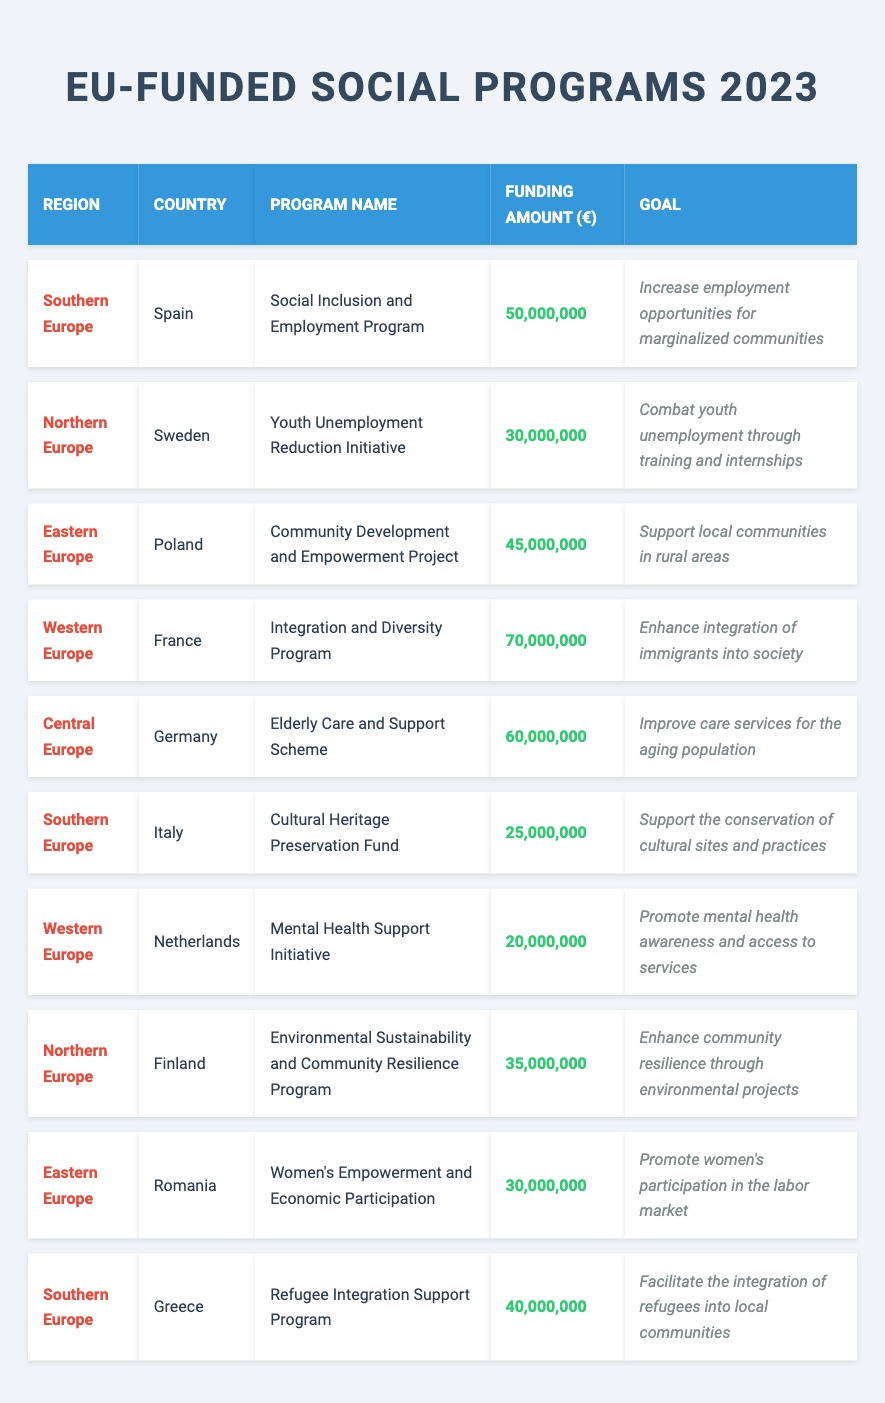What is the total funding allocated for social programs in Southern Europe? The total funding for Southern Europe can be obtained by adding the funding amounts for Spain, Italy, and Greece, which are 50,000,000 + 25,000,000 + 40,000,000 = 115,000,000.
Answer: 115,000,000 Which country received the highest funding amount for a social program in 2023? By checking the funding amounts for each program, France received the highest funding amount of 70,000,000 for the Integration and Diversity Program.
Answer: France Is there a program focused on women's empowerment in Eastern Europe? Yes, there is a program called "Women's Empowerment and Economic Participation" in Romania, which aims to promote women's participation in the labor market.
Answer: Yes How much less funding did the Mental Health Support Initiative receive compared to the Integration and Diversity Program? The Mental Health Support Initiative received 20,000,000 while the Integration and Diversity Program received 70,000,000. The difference is 70,000,000 - 20,000,000 = 50,000,000.
Answer: 50,000,000 What percentage of the total funding (across all programs) is allocated to the Community Development and Empowerment Project in Poland? The total funding amounts to 50,000,000 + 30,000,000 + 45,000,000 + 70,000,000 + 60,000,000 + 25,000,000 + 20,000,000 + 35,000,000 + 30,000,000 + 40,000,000 =  430,000,000. The funding for the Community Development and Empowerment Project is 45,000,000. Therefore, the percentage is (45,000,000 / 430,000,000) * 100 ≈ 10.47%.
Answer: 10.47% How many programs received funding of 30 million euros or more? By examining the funding amounts, there are 7 programs that received funding of 30 million euros or more: Social Inclusion and Employment Program, Youth Unemployment Reduction Initiative, Community Development and Empowerment Project, Integration and Diversity Program, Elderly Care and Support Scheme, Refugee Integration Support Program, and Environmental Sustainability and Community Resilience Program.
Answer: 7 What is the combined funding for all programs in Northern Europe? Northern Europe has two programs: the Youth Unemployment Reduction Initiative funded at 30,000,000 and the Environmental Sustainability and Community Resilience Program funded at 35,000,000. Their combined funding is 30,000,000 + 35,000,000 = 65,000,000.
Answer: 65,000,000 Which region shows more funding allocation for social support programs, Southern Europe or Western Europe? Southern Europe has total funding of 115,000,000, while Western Europe has 70,000,000 + 20,000,000 = 90,000,000. Southern Europe has higher funding than Western Europe.
Answer: Southern Europe Have any programs received funding specifically aimed at improving mental health? Yes, the Mental Health Support Initiative in the Netherlands has received funding aimed at promoting mental health awareness and access to services.
Answer: Yes Which social program has the least funding amount and what is its name? The program with the least funding amount is the Mental Health Support Initiative in the Netherlands, which received 20,000,000.
Answer: Mental Health Support Initiative How does the funding for the Cultural Heritage Preservation Fund in Italy compare to the funding for the Refugee Integration Support Program in Greece? The Cultural Heritage Preservation Fund in Italy received 25,000,000, whereas the Refugee Integration Support Program in Greece received 40,000,000. Thus, the Refugee Integration Support Program received 15,000,000 more than the Cultural Heritage Preservation Fund.
Answer: 15,000,000 more 